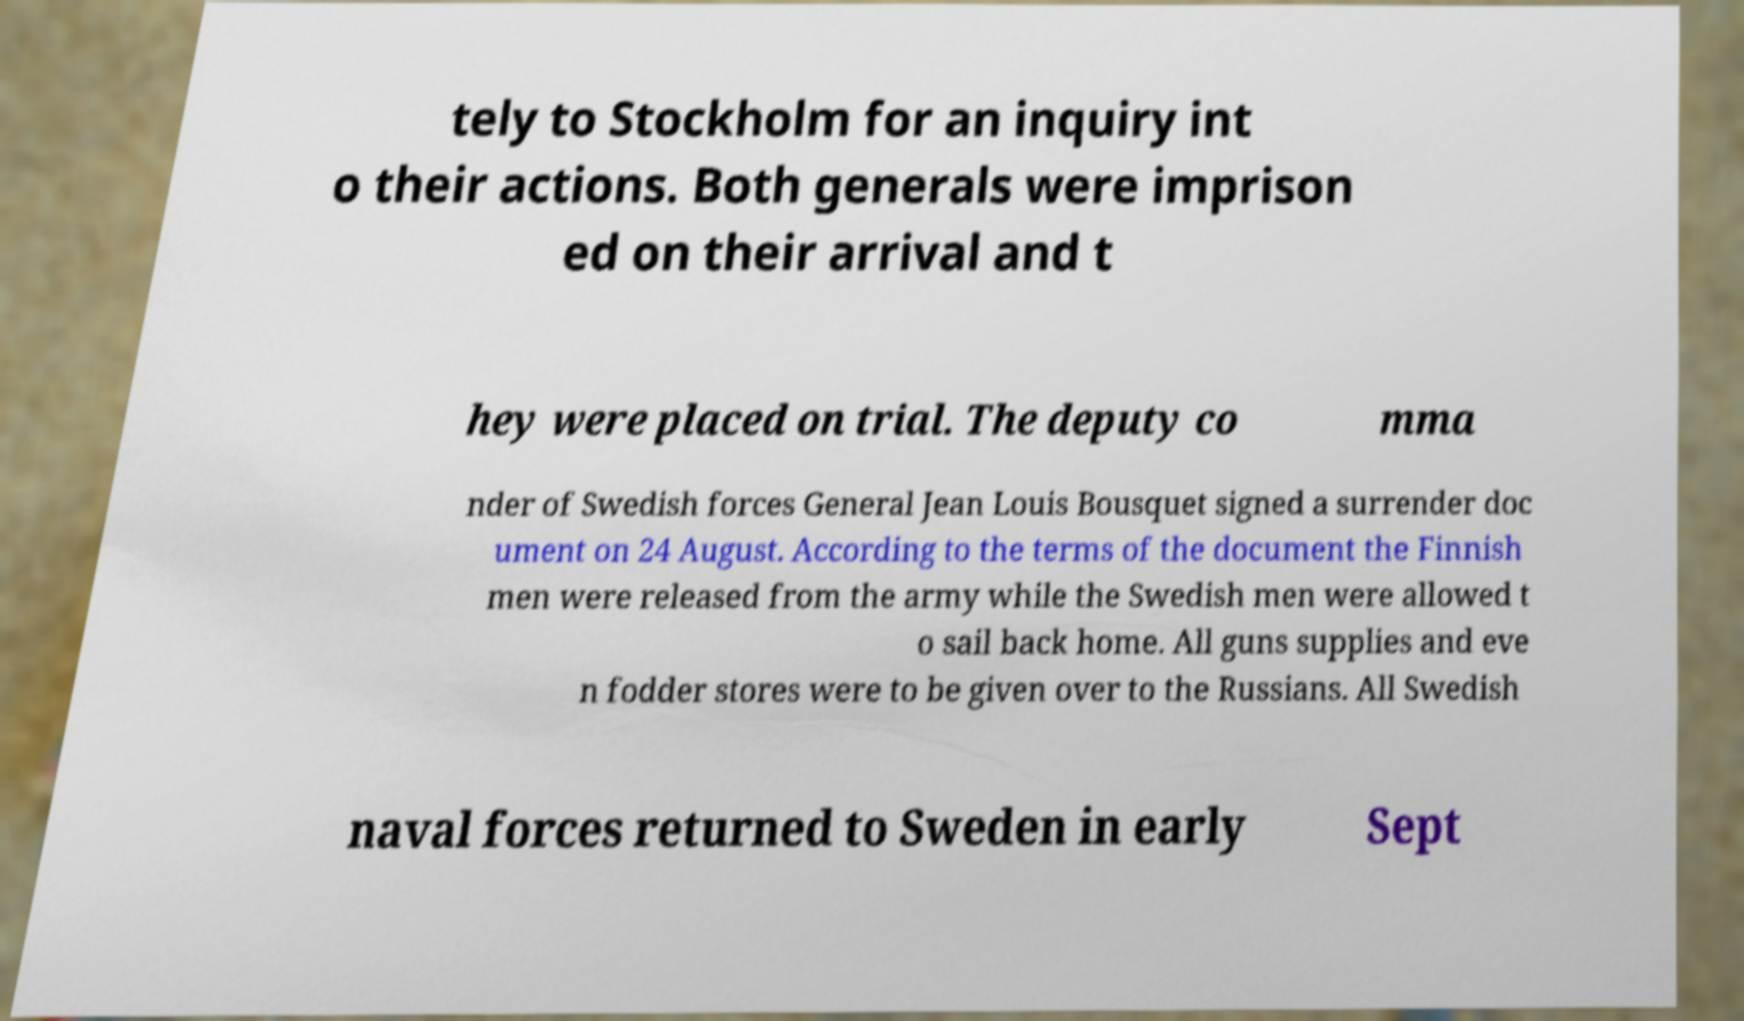For documentation purposes, I need the text within this image transcribed. Could you provide that? tely to Stockholm for an inquiry int o their actions. Both generals were imprison ed on their arrival and t hey were placed on trial. The deputy co mma nder of Swedish forces General Jean Louis Bousquet signed a surrender doc ument on 24 August. According to the terms of the document the Finnish men were released from the army while the Swedish men were allowed t o sail back home. All guns supplies and eve n fodder stores were to be given over to the Russians. All Swedish naval forces returned to Sweden in early Sept 